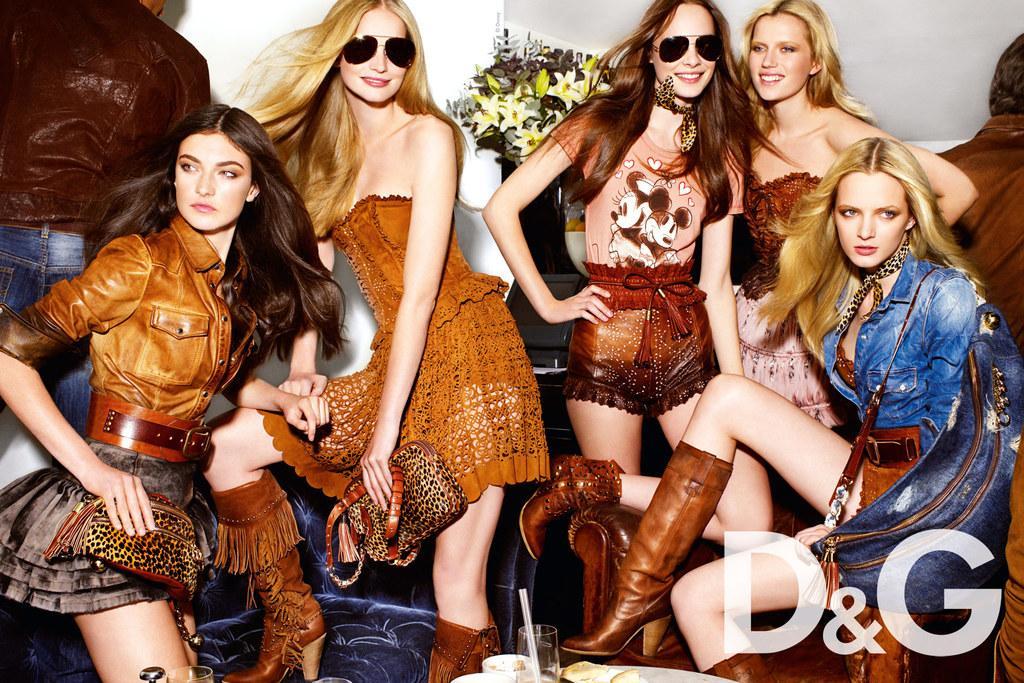Could you give a brief overview of what you see in this image? In this image I can see few people are wearing different color dresses and one person is sitting on chair. I can see the flowerpot and the wall. In front I can see few glasses and few objects. 